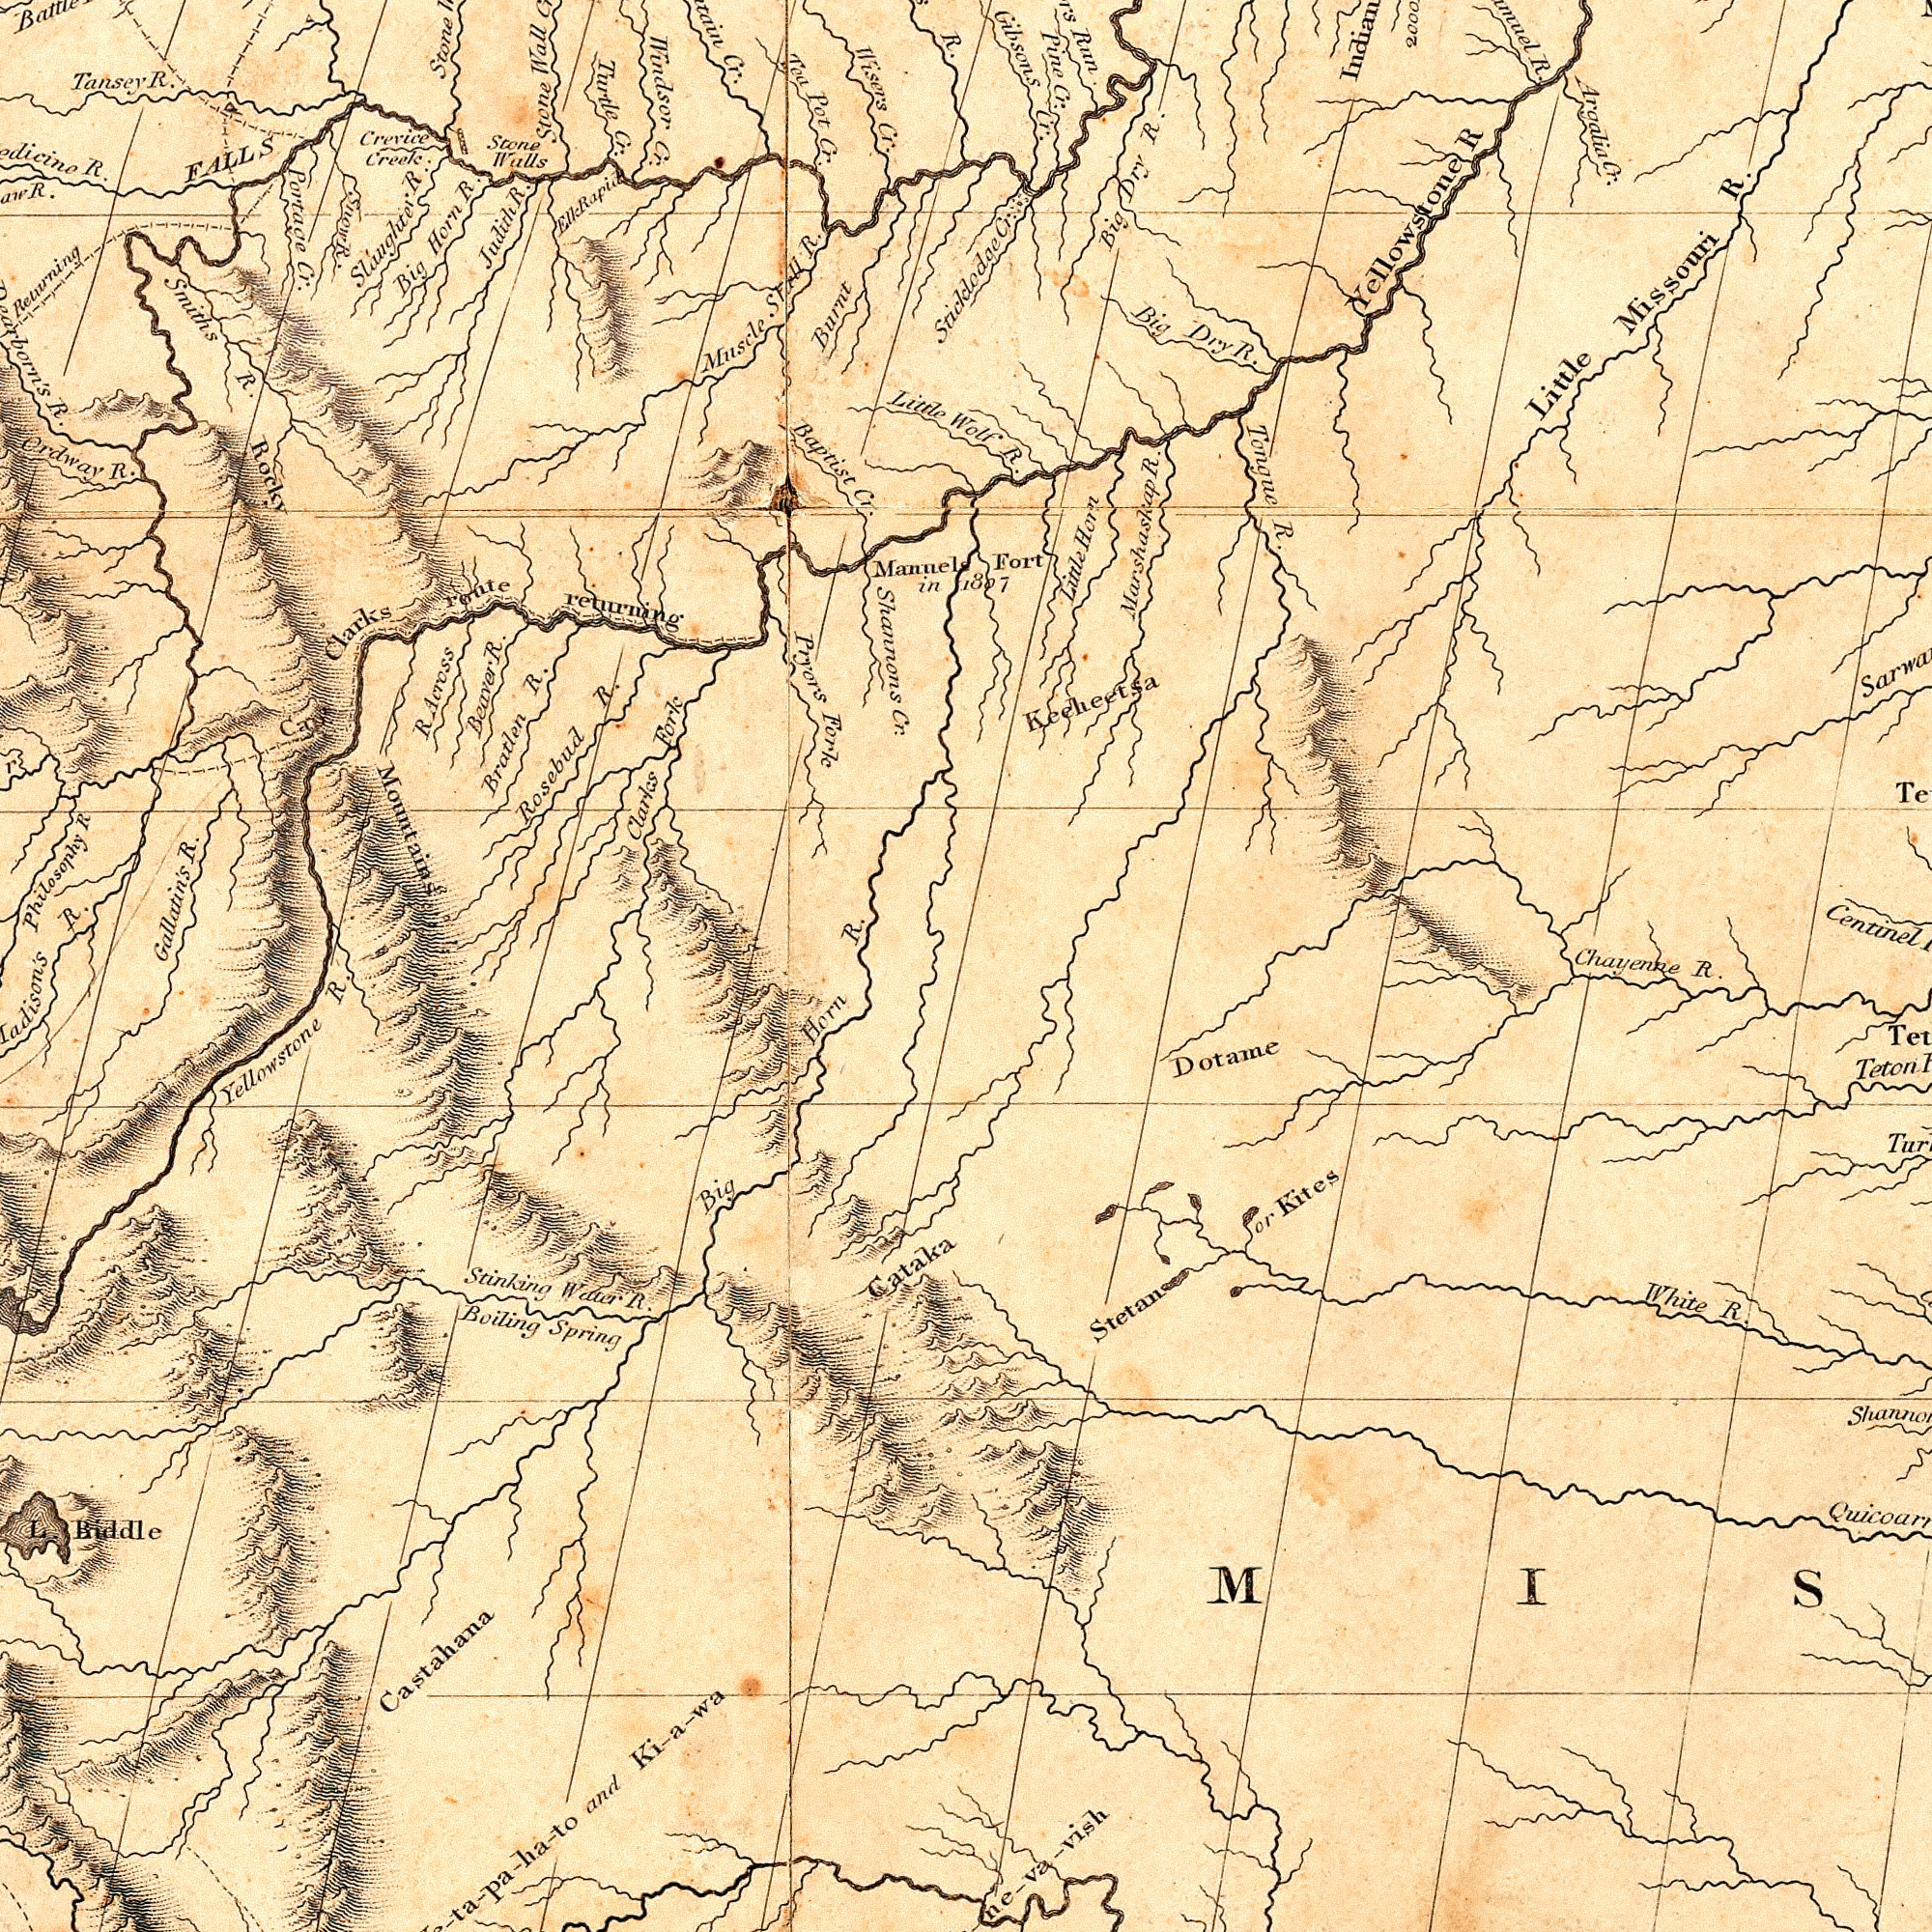What text is shown in the top-left quadrant? Windsor R. Mountains returning Portage Turtle Rosebud Pryors Baptist Fork Stone Rocky Bratlen R. Little Ordway Tansey Tea Clarles Wisers R. Philosophy Cr. R. Big Muscle FALLS Burnt Judith Cr. Pot R. R Across Horn R. Cr. R. route Mannel R. Cr. Smiths Stone R. Fork Cr Stall Creek Clarks R. Snow Stone Slaughter Cr. Returning Wall R. Shannons R. R. Cr. in R. Walls Beaver R. Cr. R. Crevice Elk Sticklodge R. Rapid What text appears in the bottom-left area of the image? R. R. Gallatin's Castahana Big Stinking Water Boiling and Horn R. Yellowstone Biddle Ki-a-wa R. Spring Cataka L. What text is shown in the bottom-right quadrant? Centinel Chayenne Dotame Kites Teton White R. Stetan or R. What text appears in the top-right area of the image? Gibsons R. Tongue R. Argalia R. R Run Fort Little R. R. Big Missouri R. Big Little Horn Pine Cr. Dry 1807 Yellowstone Dry Keeheetsa R. Cr. Cr. Cr. Marshaskap Wolf 